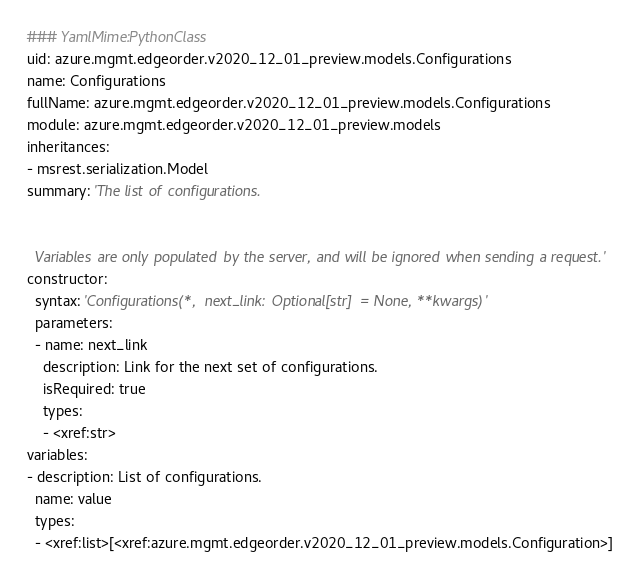Convert code to text. <code><loc_0><loc_0><loc_500><loc_500><_YAML_>### YamlMime:PythonClass
uid: azure.mgmt.edgeorder.v2020_12_01_preview.models.Configurations
name: Configurations
fullName: azure.mgmt.edgeorder.v2020_12_01_preview.models.Configurations
module: azure.mgmt.edgeorder.v2020_12_01_preview.models
inheritances:
- msrest.serialization.Model
summary: 'The list of configurations.


  Variables are only populated by the server, and will be ignored when sending a request.'
constructor:
  syntax: 'Configurations(*, next_link: Optional[str] = None, **kwargs)'
  parameters:
  - name: next_link
    description: Link for the next set of configurations.
    isRequired: true
    types:
    - <xref:str>
variables:
- description: List of configurations.
  name: value
  types:
  - <xref:list>[<xref:azure.mgmt.edgeorder.v2020_12_01_preview.models.Configuration>]
</code> 